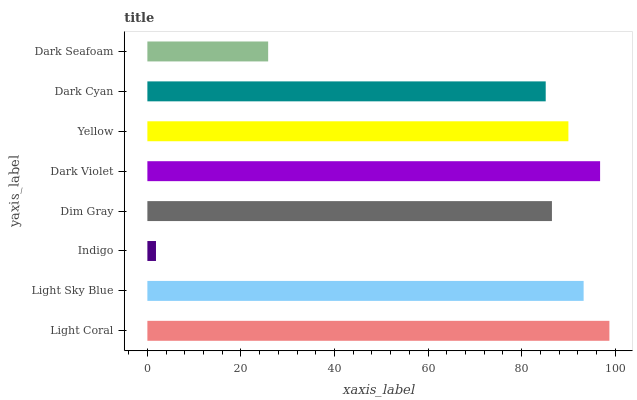Is Indigo the minimum?
Answer yes or no. Yes. Is Light Coral the maximum?
Answer yes or no. Yes. Is Light Sky Blue the minimum?
Answer yes or no. No. Is Light Sky Blue the maximum?
Answer yes or no. No. Is Light Coral greater than Light Sky Blue?
Answer yes or no. Yes. Is Light Sky Blue less than Light Coral?
Answer yes or no. Yes. Is Light Sky Blue greater than Light Coral?
Answer yes or no. No. Is Light Coral less than Light Sky Blue?
Answer yes or no. No. Is Yellow the high median?
Answer yes or no. Yes. Is Dim Gray the low median?
Answer yes or no. Yes. Is Dark Seafoam the high median?
Answer yes or no. No. Is Yellow the low median?
Answer yes or no. No. 